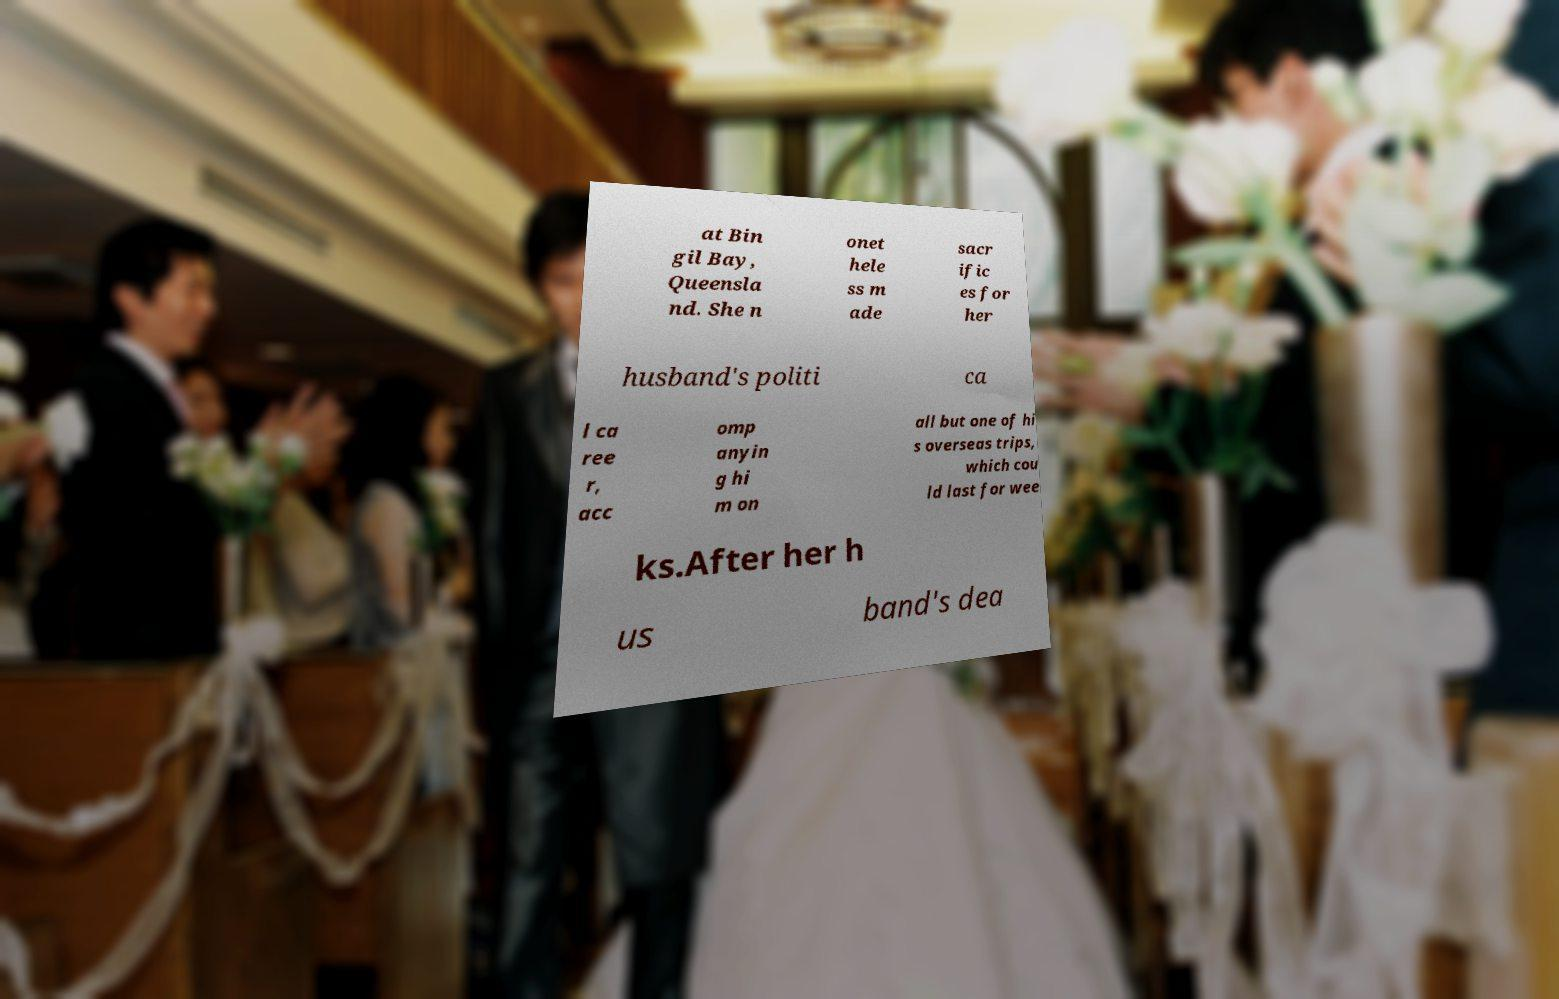Could you extract and type out the text from this image? at Bin gil Bay, Queensla nd. She n onet hele ss m ade sacr ific es for her husband's politi ca l ca ree r, acc omp anyin g hi m on all but one of hi s overseas trips, which cou ld last for wee ks.After her h us band's dea 